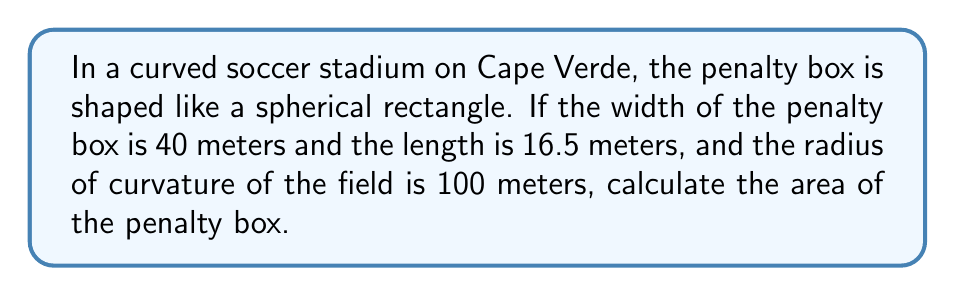Solve this math problem. To solve this problem, we need to use the formula for the area of a spherical rectangle:

$$A = 4R^2 \arcsin\left(\frac{\sin(a/2R)\sin(b/2R)}{\cos(a/2R)\cos(b/2R)}\right)$$

Where:
$A$ is the area of the spherical rectangle
$R$ is the radius of curvature
$a$ is the width of the rectangle
$b$ is the length of the rectangle

Let's substitute our values:
$R = 100$ meters
$a = 40$ meters
$b = 16.5$ meters

Step 1: Calculate $a/2R$ and $b/2R$
$$a/2R = 40/(2*100) = 0.2$$
$$b/2R = 16.5/(2*100) = 0.0825$$

Step 2: Calculate $\sin(a/2R)$, $\sin(b/2R)$, $\cos(a/2R)$, and $\cos(b/2R)$
$$\sin(0.2) \approx 0.1987$$
$$\sin(0.0825) \approx 0.0824$$
$$\cos(0.2) \approx 0.9801$$
$$\cos(0.0825) \approx 0.9966$$

Step 3: Substitute these values into the formula
$$A = 4(100)^2 \arcsin\left(\frac{0.1987 * 0.0824}{0.9801 * 0.9966}\right)$$

Step 4: Simplify
$$A = 40000 \arcsin(0.0167)$$

Step 5: Calculate the final result
$$A \approx 668.37 \text{ square meters}$$
Answer: $668.37 \text{ m}^2$ 